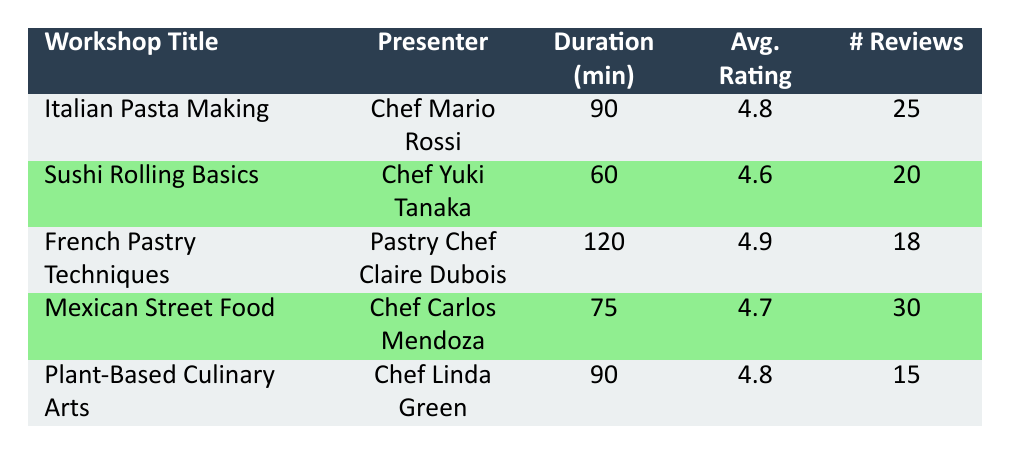What is the average rating of the "French Pastry Techniques" workshop? The table shows that the average rating for the "French Pastry Techniques" workshop is listed directly in the corresponding row, which is 4.9.
Answer: 4.9 How many participants attended the "Mexican Street Food" workshop? The number of participants for the "Mexican Street Food" workshop is provided in the table as 35, which is directly taken from that row.
Answer: 35 Which workshop had the highest average rating? By comparing all the average ratings listed in the table, it is clear that the "French Pastry Techniques" workshop has the highest rating at 4.9. This was determined by directly looking at each average rating in the table.
Answer: French Pastry Techniques Is the number of reviews for the "Plant-Based Culinary Arts" workshop greater than the number for the "Sushi Rolling Basics" workshop? The table shows that "Plant-Based Culinary Arts" has 15 reviews and "Sushi Rolling Basics" has 20 reviews. Since 15 is less than 20, the statement is false.
Answer: No What is the total duration of all workshops combined? To find the total duration, we sum the individual durations: 90 + 60 + 120 + 75 + 90 = 435 minutes. Therefore, the total duration of all workshops is 435 minutes.
Answer: 435 minutes Did "Chef Mario Rossi" have more participants than "Chef Carlos Mendoza"? According to the table, Chef Mario Rossi's workshop had 30 participants while Chef Carlos Mendoza's had 35 participants. Since 30 is less than 35, the answer is false.
Answer: No How many reviews were submitted for all workshops combined? The number of reviews for each workshop is: 25 + 20 + 18 + 30 + 15. Adding these gives us a total of 108 reviews across all workshops.
Answer: 108 reviews Which presenter had the shortest workshop duration? The workshop duration for each presenter is compared, and the shortest one is Chef Yuki Tanaka's "Sushi Rolling Basics" at 60 minutes. This was determined by examining the duration values in the table.
Answer: Chef Yuki Tanaka What is the difference in average ratings between the "Italian Pasta Making" and "Mexican Street Food" workshops? The average rating for "Italian Pasta Making" is 4.8 and for "Mexican Street Food" is 4.7. The difference is calculated as 4.8 - 4.7 = 0.1. Thus, the difference in average ratings is 0.1.
Answer: 0.1 